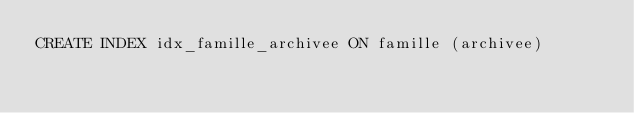Convert code to text. <code><loc_0><loc_0><loc_500><loc_500><_SQL_>CREATE INDEX idx_famille_archivee ON famille (archivee)</code> 